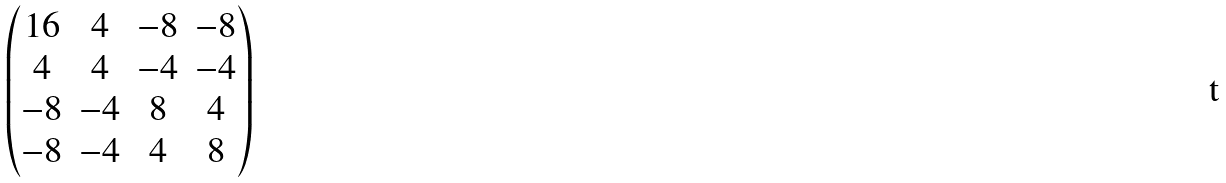Convert formula to latex. <formula><loc_0><loc_0><loc_500><loc_500>\begin{pmatrix} 1 6 & 4 & - 8 & - 8 \\ 4 & 4 & - 4 & - 4 \\ - 8 & - 4 & 8 & 4 \\ - 8 & - 4 & 4 & 8 \end{pmatrix}</formula> 